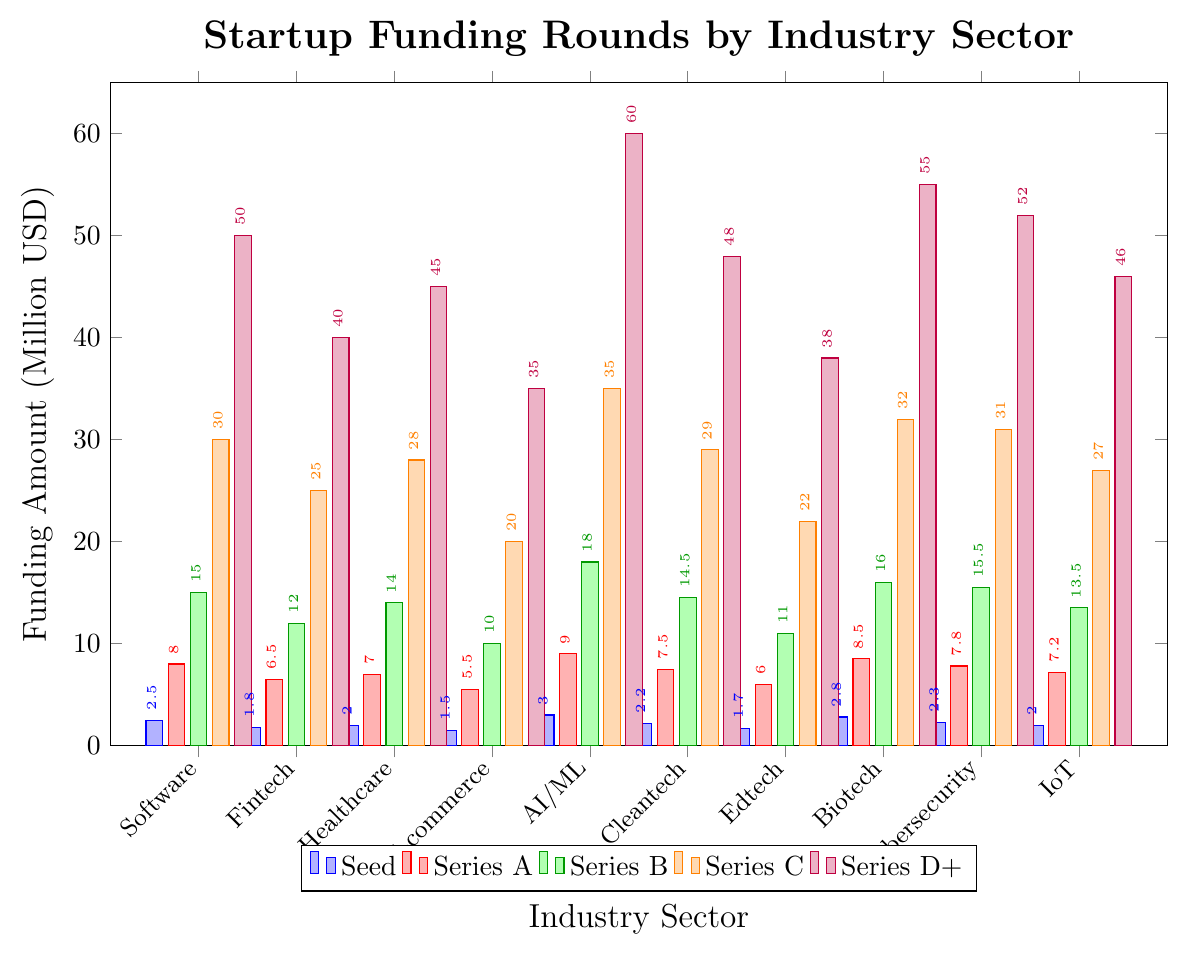What's the highest Series A funding among the industry sectors? The bar representing AI/ML in Series A is the tallest, indicating it has the highest funding in that series.
Answer: 9.0 million USD Which industry has the lowest Seed funding? The shortest bar in the Seed category is for E-commerce, indicating it has the lowest Seed funding.
Answer: 1.5 million USD How much more funding does Biotech receive in Series C than Edtech? Biotech's Series C funding is 32.0 million USD and Edtech's is 22.0 million USD. The difference is 32.0 - 22.0 = 10 million USD.
Answer: 10 million USD Compare the total funding of AI/ML and IoT in Series B, Series C, and Series D+ AI/ML's Series B (18.0), Series C (35.0), and Series D+ (60.0) add up to 18.0 + 35.0 + 60.0 = 113 million USD. IoT's Series B (13.5), Series C (27.0), and Series D+ (46.0) add up to 13.5 + 27.0 + 46.0 = 86.5 million USD. AI/ML has higher total funding.
Answer: AI/ML has higher total funding Does Cybersecurity have higher Series D+ funding than Cleantech? The bar for Cybersecurity in Series D+ is higher than Cleantech. Cybersecurity has 52.0 million USD, while Cleantech has 48.0 million USD.
Answer: Yes Which industry has the second highest funding in Series B? The height of the bars indicates that the second highest Series B funding is Biotech with 16.0 million USD.
Answer: Biotech What is the average Series C funding across all industries? Sum all Series C funding amounts: 30.0 (Software) + 25.0 (Fintech) + 28.0 (Healthcare) + 20.0 (E-commerce) + 35.0 (AI/ML) + 29.0 (Cleantech) + 22.0 (Edtech) + 32.0 (Biotech) + 31.0 (Cybersecurity) + 27.0 (IoT) = 279 million USD. Average is 279 / 10 = 27.9 million USD.
Answer: 27.9 million USD Is the Series B funding in Healthcare higher than in Fintech? The bar for Series B in Healthcare is higher than in Fintech. Healthcare has 14.0 million USD, while Fintech has 12.0 million USD.
Answer: Yes How does the Series A funding for Software compare to Fintech? The bar for Software in Series A is higher, indicating it has more funding at 8.0 million USD compared to Fintech's 6.5 million USD.
Answer: Software is higher 